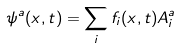<formula> <loc_0><loc_0><loc_500><loc_500>\psi ^ { a } ( { x } , t ) = \sum _ { i } f _ { i } ( { x } , t ) A _ { i } ^ { a }</formula> 